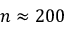Convert formula to latex. <formula><loc_0><loc_0><loc_500><loc_500>n \approx 2 0 0</formula> 